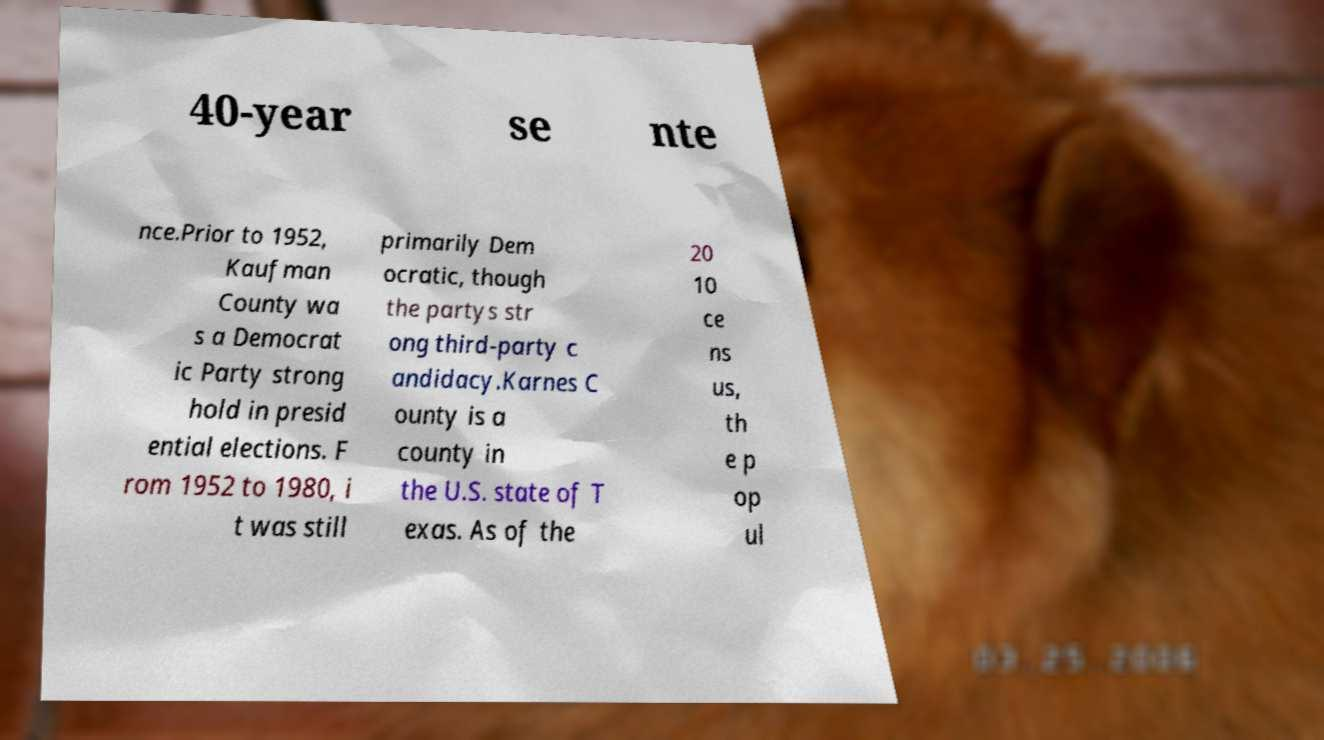Please read and relay the text visible in this image. What does it say? 40-year se nte nce.Prior to 1952, Kaufman County wa s a Democrat ic Party strong hold in presid ential elections. F rom 1952 to 1980, i t was still primarily Dem ocratic, though the partys str ong third-party c andidacy.Karnes C ounty is a county in the U.S. state of T exas. As of the 20 10 ce ns us, th e p op ul 